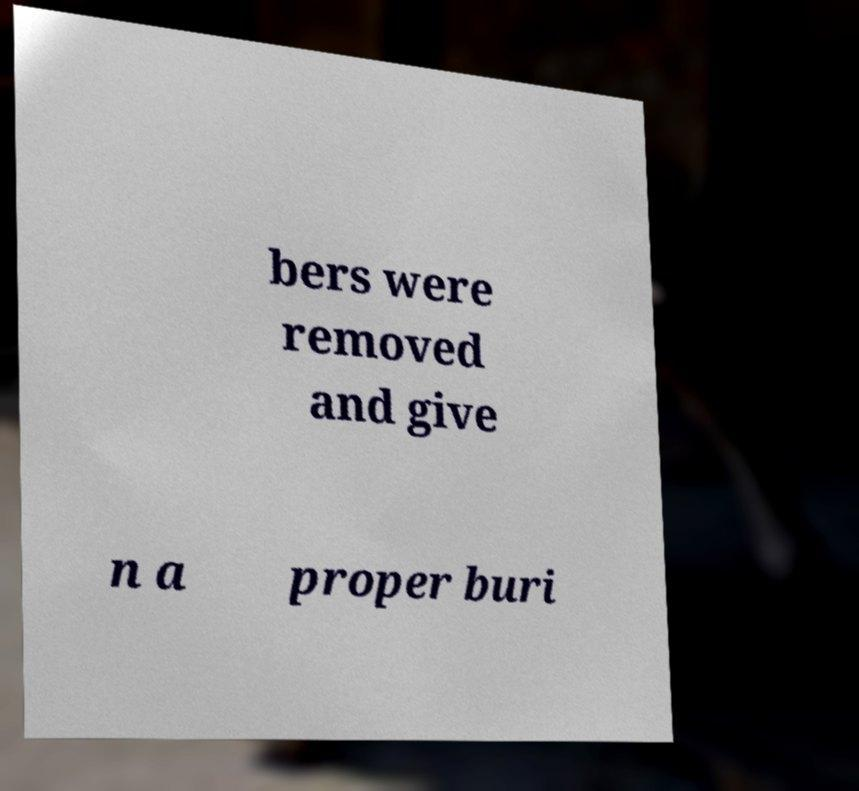Can you read and provide the text displayed in the image?This photo seems to have some interesting text. Can you extract and type it out for me? bers were removed and give n a proper buri 